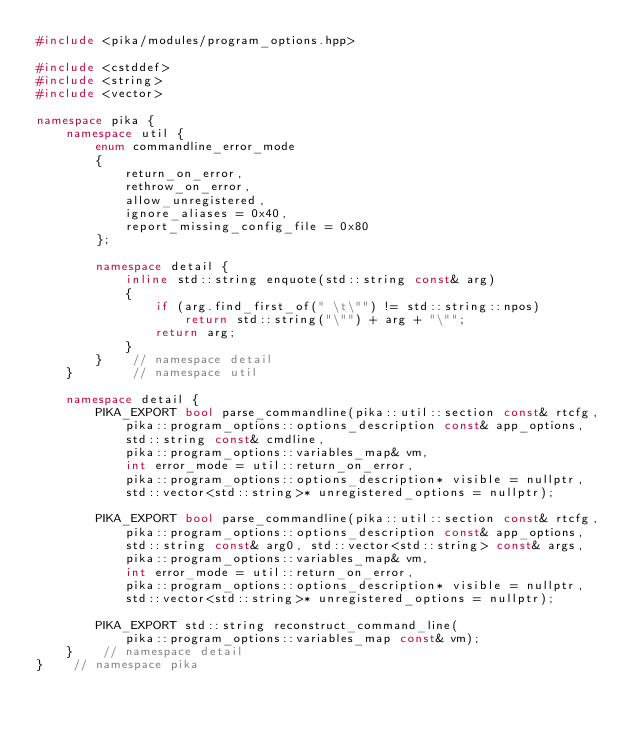<code> <loc_0><loc_0><loc_500><loc_500><_C++_>#include <pika/modules/program_options.hpp>

#include <cstddef>
#include <string>
#include <vector>

namespace pika {
    namespace util {
        enum commandline_error_mode
        {
            return_on_error,
            rethrow_on_error,
            allow_unregistered,
            ignore_aliases = 0x40,
            report_missing_config_file = 0x80
        };

        namespace detail {
            inline std::string enquote(std::string const& arg)
            {
                if (arg.find_first_of(" \t\"") != std::string::npos)
                    return std::string("\"") + arg + "\"";
                return arg;
            }
        }    // namespace detail
    }        // namespace util

    namespace detail {
        PIKA_EXPORT bool parse_commandline(pika::util::section const& rtcfg,
            pika::program_options::options_description const& app_options,
            std::string const& cmdline,
            pika::program_options::variables_map& vm,
            int error_mode = util::return_on_error,
            pika::program_options::options_description* visible = nullptr,
            std::vector<std::string>* unregistered_options = nullptr);

        PIKA_EXPORT bool parse_commandline(pika::util::section const& rtcfg,
            pika::program_options::options_description const& app_options,
            std::string const& arg0, std::vector<std::string> const& args,
            pika::program_options::variables_map& vm,
            int error_mode = util::return_on_error,
            pika::program_options::options_description* visible = nullptr,
            std::vector<std::string>* unregistered_options = nullptr);

        PIKA_EXPORT std::string reconstruct_command_line(
            pika::program_options::variables_map const& vm);
    }    // namespace detail
}    // namespace pika
</code> 